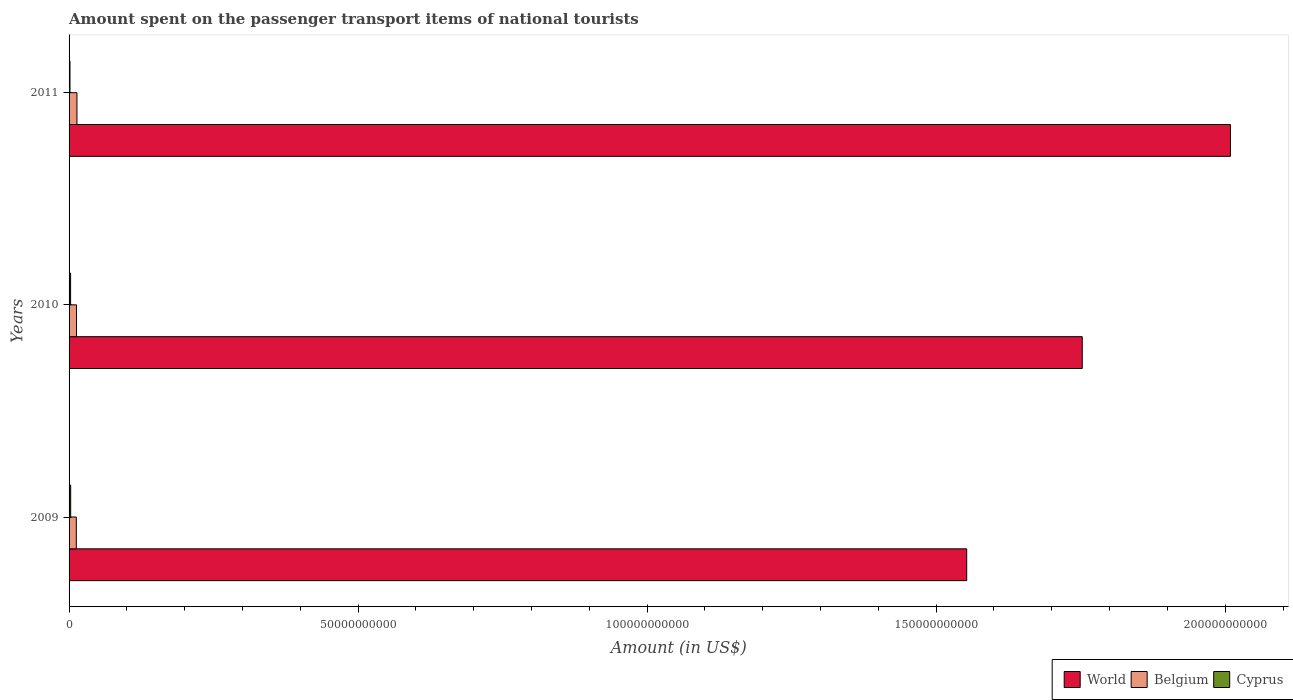How many different coloured bars are there?
Your response must be concise. 3. How many groups of bars are there?
Your response must be concise. 3. Are the number of bars per tick equal to the number of legend labels?
Make the answer very short. Yes. How many bars are there on the 3rd tick from the bottom?
Offer a very short reply. 3. What is the label of the 1st group of bars from the top?
Your response must be concise. 2011. In how many cases, is the number of bars for a given year not equal to the number of legend labels?
Keep it short and to the point. 0. What is the amount spent on the passenger transport items of national tourists in Belgium in 2011?
Your response must be concise. 1.36e+09. Across all years, what is the maximum amount spent on the passenger transport items of national tourists in World?
Give a very brief answer. 2.01e+11. Across all years, what is the minimum amount spent on the passenger transport items of national tourists in World?
Keep it short and to the point. 1.55e+11. In which year was the amount spent on the passenger transport items of national tourists in World maximum?
Your answer should be very brief. 2011. In which year was the amount spent on the passenger transport items of national tourists in Cyprus minimum?
Offer a very short reply. 2011. What is the total amount spent on the passenger transport items of national tourists in Cyprus in the graph?
Offer a terse response. 6.99e+08. What is the difference between the amount spent on the passenger transport items of national tourists in Cyprus in 2009 and that in 2011?
Provide a short and direct response. 1.22e+08. What is the difference between the amount spent on the passenger transport items of national tourists in Cyprus in 2009 and the amount spent on the passenger transport items of national tourists in World in 2011?
Ensure brevity in your answer.  -2.01e+11. What is the average amount spent on the passenger transport items of national tourists in Cyprus per year?
Offer a terse response. 2.33e+08. In the year 2010, what is the difference between the amount spent on the passenger transport items of national tourists in World and amount spent on the passenger transport items of national tourists in Belgium?
Your response must be concise. 1.74e+11. What is the ratio of the amount spent on the passenger transport items of national tourists in World in 2010 to that in 2011?
Your answer should be compact. 0.87. What is the difference between the highest and the second highest amount spent on the passenger transport items of national tourists in Cyprus?
Your answer should be compact. 1.60e+07. What is the difference between the highest and the lowest amount spent on the passenger transport items of national tourists in Cyprus?
Your answer should be very brief. 1.22e+08. In how many years, is the amount spent on the passenger transport items of national tourists in World greater than the average amount spent on the passenger transport items of national tourists in World taken over all years?
Your answer should be very brief. 1. What does the 1st bar from the top in 2011 represents?
Provide a short and direct response. Cyprus. What does the 2nd bar from the bottom in 2009 represents?
Offer a very short reply. Belgium. Is it the case that in every year, the sum of the amount spent on the passenger transport items of national tourists in Belgium and amount spent on the passenger transport items of national tourists in World is greater than the amount spent on the passenger transport items of national tourists in Cyprus?
Offer a very short reply. Yes. How many bars are there?
Your answer should be compact. 9. Are all the bars in the graph horizontal?
Give a very brief answer. Yes. How many years are there in the graph?
Your answer should be very brief. 3. What is the difference between two consecutive major ticks on the X-axis?
Your response must be concise. 5.00e+1. Does the graph contain grids?
Ensure brevity in your answer.  No. Where does the legend appear in the graph?
Offer a very short reply. Bottom right. How are the legend labels stacked?
Your answer should be very brief. Horizontal. What is the title of the graph?
Offer a very short reply. Amount spent on the passenger transport items of national tourists. What is the label or title of the X-axis?
Give a very brief answer. Amount (in US$). What is the label or title of the Y-axis?
Offer a very short reply. Years. What is the Amount (in US$) of World in 2009?
Give a very brief answer. 1.55e+11. What is the Amount (in US$) of Belgium in 2009?
Provide a succinct answer. 1.25e+09. What is the Amount (in US$) in Cyprus in 2009?
Your answer should be compact. 2.79e+08. What is the Amount (in US$) in World in 2010?
Provide a short and direct response. 1.75e+11. What is the Amount (in US$) in Belgium in 2010?
Provide a short and direct response. 1.29e+09. What is the Amount (in US$) in Cyprus in 2010?
Your answer should be very brief. 2.63e+08. What is the Amount (in US$) of World in 2011?
Your response must be concise. 2.01e+11. What is the Amount (in US$) of Belgium in 2011?
Your answer should be compact. 1.36e+09. What is the Amount (in US$) in Cyprus in 2011?
Ensure brevity in your answer.  1.57e+08. Across all years, what is the maximum Amount (in US$) in World?
Provide a short and direct response. 2.01e+11. Across all years, what is the maximum Amount (in US$) in Belgium?
Your response must be concise. 1.36e+09. Across all years, what is the maximum Amount (in US$) of Cyprus?
Make the answer very short. 2.79e+08. Across all years, what is the minimum Amount (in US$) in World?
Keep it short and to the point. 1.55e+11. Across all years, what is the minimum Amount (in US$) in Belgium?
Give a very brief answer. 1.25e+09. Across all years, what is the minimum Amount (in US$) of Cyprus?
Offer a very short reply. 1.57e+08. What is the total Amount (in US$) in World in the graph?
Provide a short and direct response. 5.31e+11. What is the total Amount (in US$) of Belgium in the graph?
Ensure brevity in your answer.  3.90e+09. What is the total Amount (in US$) of Cyprus in the graph?
Ensure brevity in your answer.  6.99e+08. What is the difference between the Amount (in US$) of World in 2009 and that in 2010?
Give a very brief answer. -2.00e+1. What is the difference between the Amount (in US$) in Belgium in 2009 and that in 2010?
Your answer should be very brief. -3.30e+07. What is the difference between the Amount (in US$) of Cyprus in 2009 and that in 2010?
Provide a short and direct response. 1.60e+07. What is the difference between the Amount (in US$) of World in 2009 and that in 2011?
Offer a very short reply. -4.56e+1. What is the difference between the Amount (in US$) in Belgium in 2009 and that in 2011?
Your answer should be very brief. -1.10e+08. What is the difference between the Amount (in US$) in Cyprus in 2009 and that in 2011?
Provide a succinct answer. 1.22e+08. What is the difference between the Amount (in US$) in World in 2010 and that in 2011?
Keep it short and to the point. -2.56e+1. What is the difference between the Amount (in US$) of Belgium in 2010 and that in 2011?
Your response must be concise. -7.70e+07. What is the difference between the Amount (in US$) in Cyprus in 2010 and that in 2011?
Your response must be concise. 1.06e+08. What is the difference between the Amount (in US$) in World in 2009 and the Amount (in US$) in Belgium in 2010?
Make the answer very short. 1.54e+11. What is the difference between the Amount (in US$) of World in 2009 and the Amount (in US$) of Cyprus in 2010?
Keep it short and to the point. 1.55e+11. What is the difference between the Amount (in US$) of Belgium in 2009 and the Amount (in US$) of Cyprus in 2010?
Keep it short and to the point. 9.91e+08. What is the difference between the Amount (in US$) of World in 2009 and the Amount (in US$) of Belgium in 2011?
Keep it short and to the point. 1.54e+11. What is the difference between the Amount (in US$) in World in 2009 and the Amount (in US$) in Cyprus in 2011?
Ensure brevity in your answer.  1.55e+11. What is the difference between the Amount (in US$) of Belgium in 2009 and the Amount (in US$) of Cyprus in 2011?
Provide a succinct answer. 1.10e+09. What is the difference between the Amount (in US$) of World in 2010 and the Amount (in US$) of Belgium in 2011?
Your response must be concise. 1.74e+11. What is the difference between the Amount (in US$) in World in 2010 and the Amount (in US$) in Cyprus in 2011?
Your answer should be very brief. 1.75e+11. What is the difference between the Amount (in US$) of Belgium in 2010 and the Amount (in US$) of Cyprus in 2011?
Provide a succinct answer. 1.13e+09. What is the average Amount (in US$) of World per year?
Your answer should be very brief. 1.77e+11. What is the average Amount (in US$) in Belgium per year?
Provide a succinct answer. 1.30e+09. What is the average Amount (in US$) of Cyprus per year?
Your response must be concise. 2.33e+08. In the year 2009, what is the difference between the Amount (in US$) of World and Amount (in US$) of Belgium?
Offer a very short reply. 1.54e+11. In the year 2009, what is the difference between the Amount (in US$) of World and Amount (in US$) of Cyprus?
Your response must be concise. 1.55e+11. In the year 2009, what is the difference between the Amount (in US$) of Belgium and Amount (in US$) of Cyprus?
Make the answer very short. 9.75e+08. In the year 2010, what is the difference between the Amount (in US$) of World and Amount (in US$) of Belgium?
Provide a short and direct response. 1.74e+11. In the year 2010, what is the difference between the Amount (in US$) in World and Amount (in US$) in Cyprus?
Make the answer very short. 1.75e+11. In the year 2010, what is the difference between the Amount (in US$) of Belgium and Amount (in US$) of Cyprus?
Your answer should be compact. 1.02e+09. In the year 2011, what is the difference between the Amount (in US$) of World and Amount (in US$) of Belgium?
Your answer should be compact. 2.00e+11. In the year 2011, what is the difference between the Amount (in US$) in World and Amount (in US$) in Cyprus?
Ensure brevity in your answer.  2.01e+11. In the year 2011, what is the difference between the Amount (in US$) of Belgium and Amount (in US$) of Cyprus?
Your response must be concise. 1.21e+09. What is the ratio of the Amount (in US$) in World in 2009 to that in 2010?
Give a very brief answer. 0.89. What is the ratio of the Amount (in US$) in Belgium in 2009 to that in 2010?
Provide a short and direct response. 0.97. What is the ratio of the Amount (in US$) in Cyprus in 2009 to that in 2010?
Provide a short and direct response. 1.06. What is the ratio of the Amount (in US$) in World in 2009 to that in 2011?
Give a very brief answer. 0.77. What is the ratio of the Amount (in US$) in Belgium in 2009 to that in 2011?
Offer a terse response. 0.92. What is the ratio of the Amount (in US$) of Cyprus in 2009 to that in 2011?
Make the answer very short. 1.78. What is the ratio of the Amount (in US$) of World in 2010 to that in 2011?
Provide a short and direct response. 0.87. What is the ratio of the Amount (in US$) of Belgium in 2010 to that in 2011?
Make the answer very short. 0.94. What is the ratio of the Amount (in US$) in Cyprus in 2010 to that in 2011?
Ensure brevity in your answer.  1.68. What is the difference between the highest and the second highest Amount (in US$) in World?
Offer a terse response. 2.56e+1. What is the difference between the highest and the second highest Amount (in US$) in Belgium?
Ensure brevity in your answer.  7.70e+07. What is the difference between the highest and the second highest Amount (in US$) in Cyprus?
Your answer should be compact. 1.60e+07. What is the difference between the highest and the lowest Amount (in US$) of World?
Your answer should be very brief. 4.56e+1. What is the difference between the highest and the lowest Amount (in US$) in Belgium?
Offer a terse response. 1.10e+08. What is the difference between the highest and the lowest Amount (in US$) in Cyprus?
Offer a terse response. 1.22e+08. 